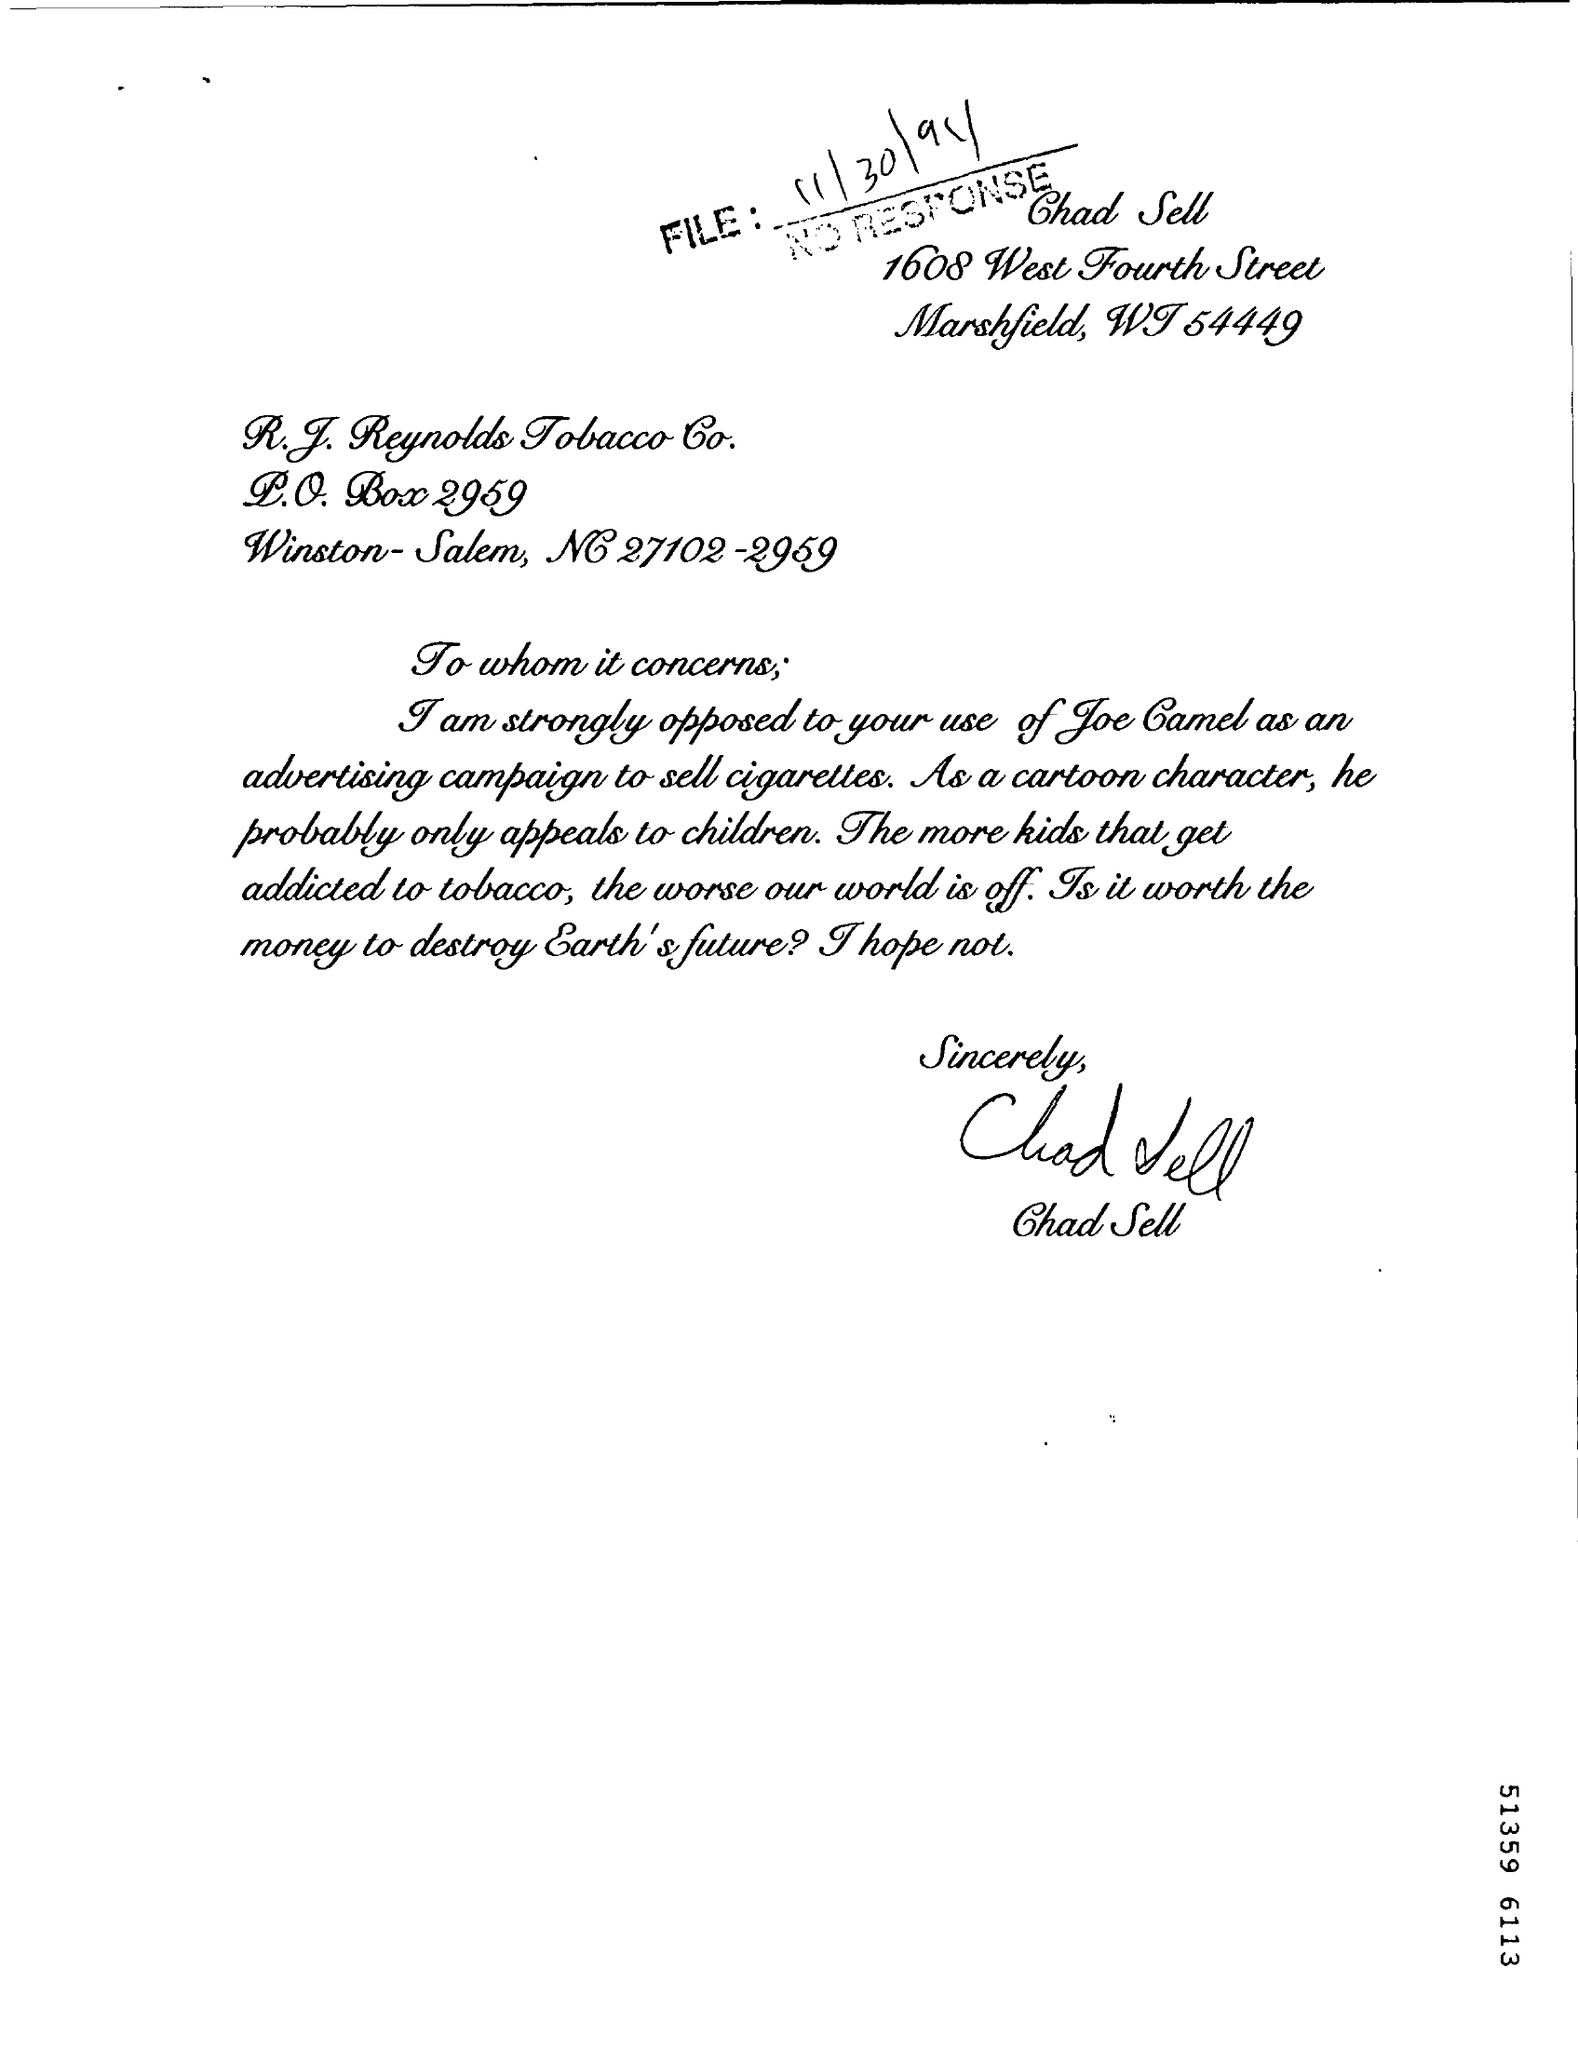Who is the author of this letter?
Ensure brevity in your answer.  Chad Sell. Which city does the author live in?
Your answer should be very brief. Marshfield. 